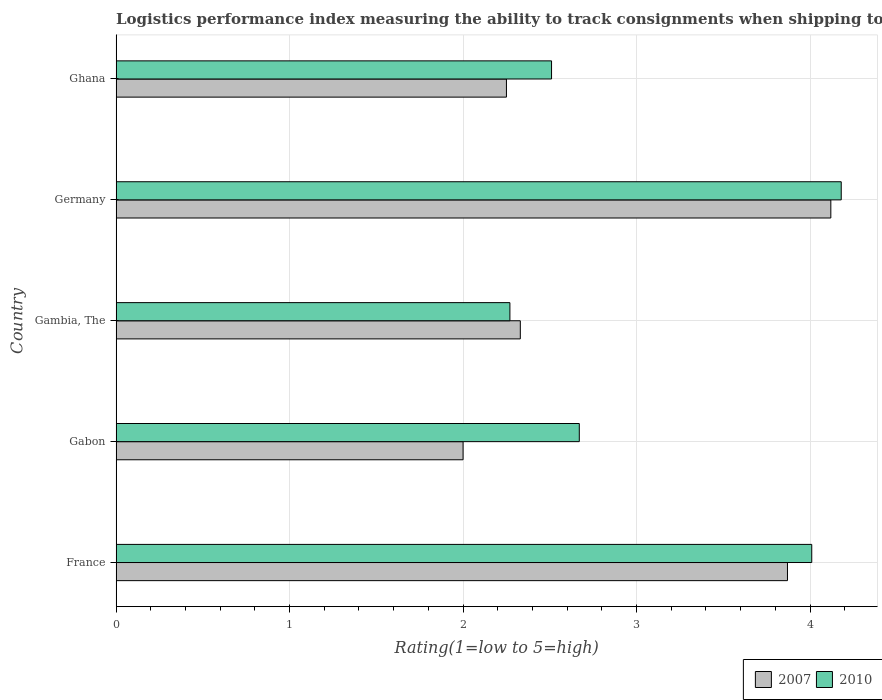How many different coloured bars are there?
Keep it short and to the point. 2. Are the number of bars per tick equal to the number of legend labels?
Keep it short and to the point. Yes. How many bars are there on the 4th tick from the bottom?
Offer a very short reply. 2. What is the Logistic performance index in 2007 in Ghana?
Provide a succinct answer. 2.25. Across all countries, what is the maximum Logistic performance index in 2010?
Give a very brief answer. 4.18. Across all countries, what is the minimum Logistic performance index in 2007?
Your answer should be very brief. 2. In which country was the Logistic performance index in 2007 minimum?
Provide a short and direct response. Gabon. What is the total Logistic performance index in 2007 in the graph?
Give a very brief answer. 14.57. What is the difference between the Logistic performance index in 2007 in Gabon and the Logistic performance index in 2010 in France?
Offer a terse response. -2.01. What is the average Logistic performance index in 2007 per country?
Give a very brief answer. 2.91. What is the difference between the Logistic performance index in 2010 and Logistic performance index in 2007 in Gabon?
Give a very brief answer. 0.67. What is the ratio of the Logistic performance index in 2007 in France to that in Germany?
Your response must be concise. 0.94. Is the Logistic performance index in 2007 in Gambia, The less than that in Germany?
Your response must be concise. Yes. Is the difference between the Logistic performance index in 2010 in Germany and Ghana greater than the difference between the Logistic performance index in 2007 in Germany and Ghana?
Your response must be concise. No. What is the difference between the highest and the second highest Logistic performance index in 2007?
Offer a very short reply. 0.25. What is the difference between the highest and the lowest Logistic performance index in 2007?
Offer a terse response. 2.12. In how many countries, is the Logistic performance index in 2010 greater than the average Logistic performance index in 2010 taken over all countries?
Make the answer very short. 2. Is the sum of the Logistic performance index in 2007 in France and Gambia, The greater than the maximum Logistic performance index in 2010 across all countries?
Your answer should be compact. Yes. What does the 2nd bar from the top in France represents?
Keep it short and to the point. 2007. What does the 2nd bar from the bottom in Gambia, The represents?
Provide a succinct answer. 2010. Are all the bars in the graph horizontal?
Your response must be concise. Yes. Are the values on the major ticks of X-axis written in scientific E-notation?
Your answer should be very brief. No. Does the graph contain any zero values?
Make the answer very short. No. Does the graph contain grids?
Keep it short and to the point. Yes. How many legend labels are there?
Keep it short and to the point. 2. How are the legend labels stacked?
Provide a succinct answer. Horizontal. What is the title of the graph?
Your answer should be very brief. Logistics performance index measuring the ability to track consignments when shipping to a market. Does "1972" appear as one of the legend labels in the graph?
Offer a very short reply. No. What is the label or title of the X-axis?
Ensure brevity in your answer.  Rating(1=low to 5=high). What is the Rating(1=low to 5=high) of 2007 in France?
Keep it short and to the point. 3.87. What is the Rating(1=low to 5=high) of 2010 in France?
Your answer should be very brief. 4.01. What is the Rating(1=low to 5=high) in 2010 in Gabon?
Provide a succinct answer. 2.67. What is the Rating(1=low to 5=high) of 2007 in Gambia, The?
Provide a short and direct response. 2.33. What is the Rating(1=low to 5=high) in 2010 in Gambia, The?
Provide a succinct answer. 2.27. What is the Rating(1=low to 5=high) of 2007 in Germany?
Make the answer very short. 4.12. What is the Rating(1=low to 5=high) of 2010 in Germany?
Make the answer very short. 4.18. What is the Rating(1=low to 5=high) of 2007 in Ghana?
Provide a succinct answer. 2.25. What is the Rating(1=low to 5=high) of 2010 in Ghana?
Provide a succinct answer. 2.51. Across all countries, what is the maximum Rating(1=low to 5=high) in 2007?
Your answer should be very brief. 4.12. Across all countries, what is the maximum Rating(1=low to 5=high) in 2010?
Provide a succinct answer. 4.18. Across all countries, what is the minimum Rating(1=low to 5=high) of 2010?
Your response must be concise. 2.27. What is the total Rating(1=low to 5=high) in 2007 in the graph?
Offer a terse response. 14.57. What is the total Rating(1=low to 5=high) of 2010 in the graph?
Provide a short and direct response. 15.64. What is the difference between the Rating(1=low to 5=high) in 2007 in France and that in Gabon?
Offer a very short reply. 1.87. What is the difference between the Rating(1=low to 5=high) in 2010 in France and that in Gabon?
Your response must be concise. 1.34. What is the difference between the Rating(1=low to 5=high) in 2007 in France and that in Gambia, The?
Provide a short and direct response. 1.54. What is the difference between the Rating(1=low to 5=high) of 2010 in France and that in Gambia, The?
Your response must be concise. 1.74. What is the difference between the Rating(1=low to 5=high) in 2010 in France and that in Germany?
Give a very brief answer. -0.17. What is the difference between the Rating(1=low to 5=high) of 2007 in France and that in Ghana?
Make the answer very short. 1.62. What is the difference between the Rating(1=low to 5=high) of 2007 in Gabon and that in Gambia, The?
Ensure brevity in your answer.  -0.33. What is the difference between the Rating(1=low to 5=high) in 2010 in Gabon and that in Gambia, The?
Your answer should be compact. 0.4. What is the difference between the Rating(1=low to 5=high) of 2007 in Gabon and that in Germany?
Make the answer very short. -2.12. What is the difference between the Rating(1=low to 5=high) in 2010 in Gabon and that in Germany?
Keep it short and to the point. -1.51. What is the difference between the Rating(1=low to 5=high) of 2010 in Gabon and that in Ghana?
Offer a terse response. 0.16. What is the difference between the Rating(1=low to 5=high) in 2007 in Gambia, The and that in Germany?
Your answer should be very brief. -1.79. What is the difference between the Rating(1=low to 5=high) in 2010 in Gambia, The and that in Germany?
Ensure brevity in your answer.  -1.91. What is the difference between the Rating(1=low to 5=high) in 2007 in Gambia, The and that in Ghana?
Your answer should be compact. 0.08. What is the difference between the Rating(1=low to 5=high) of 2010 in Gambia, The and that in Ghana?
Provide a short and direct response. -0.24. What is the difference between the Rating(1=low to 5=high) in 2007 in Germany and that in Ghana?
Provide a succinct answer. 1.87. What is the difference between the Rating(1=low to 5=high) of 2010 in Germany and that in Ghana?
Your response must be concise. 1.67. What is the difference between the Rating(1=low to 5=high) in 2007 in France and the Rating(1=low to 5=high) in 2010 in Gabon?
Provide a short and direct response. 1.2. What is the difference between the Rating(1=low to 5=high) in 2007 in France and the Rating(1=low to 5=high) in 2010 in Gambia, The?
Give a very brief answer. 1.6. What is the difference between the Rating(1=low to 5=high) of 2007 in France and the Rating(1=low to 5=high) of 2010 in Germany?
Offer a terse response. -0.31. What is the difference between the Rating(1=low to 5=high) in 2007 in France and the Rating(1=low to 5=high) in 2010 in Ghana?
Your response must be concise. 1.36. What is the difference between the Rating(1=low to 5=high) in 2007 in Gabon and the Rating(1=low to 5=high) in 2010 in Gambia, The?
Your answer should be very brief. -0.27. What is the difference between the Rating(1=low to 5=high) of 2007 in Gabon and the Rating(1=low to 5=high) of 2010 in Germany?
Offer a terse response. -2.18. What is the difference between the Rating(1=low to 5=high) of 2007 in Gabon and the Rating(1=low to 5=high) of 2010 in Ghana?
Your answer should be very brief. -0.51. What is the difference between the Rating(1=low to 5=high) in 2007 in Gambia, The and the Rating(1=low to 5=high) in 2010 in Germany?
Offer a terse response. -1.85. What is the difference between the Rating(1=low to 5=high) of 2007 in Gambia, The and the Rating(1=low to 5=high) of 2010 in Ghana?
Keep it short and to the point. -0.18. What is the difference between the Rating(1=low to 5=high) in 2007 in Germany and the Rating(1=low to 5=high) in 2010 in Ghana?
Give a very brief answer. 1.61. What is the average Rating(1=low to 5=high) of 2007 per country?
Provide a short and direct response. 2.91. What is the average Rating(1=low to 5=high) of 2010 per country?
Your answer should be very brief. 3.13. What is the difference between the Rating(1=low to 5=high) in 2007 and Rating(1=low to 5=high) in 2010 in France?
Make the answer very short. -0.14. What is the difference between the Rating(1=low to 5=high) of 2007 and Rating(1=low to 5=high) of 2010 in Gabon?
Your answer should be very brief. -0.67. What is the difference between the Rating(1=low to 5=high) in 2007 and Rating(1=low to 5=high) in 2010 in Gambia, The?
Give a very brief answer. 0.06. What is the difference between the Rating(1=low to 5=high) in 2007 and Rating(1=low to 5=high) in 2010 in Germany?
Your answer should be very brief. -0.06. What is the difference between the Rating(1=low to 5=high) in 2007 and Rating(1=low to 5=high) in 2010 in Ghana?
Give a very brief answer. -0.26. What is the ratio of the Rating(1=low to 5=high) in 2007 in France to that in Gabon?
Provide a short and direct response. 1.94. What is the ratio of the Rating(1=low to 5=high) of 2010 in France to that in Gabon?
Ensure brevity in your answer.  1.5. What is the ratio of the Rating(1=low to 5=high) of 2007 in France to that in Gambia, The?
Your answer should be very brief. 1.66. What is the ratio of the Rating(1=low to 5=high) in 2010 in France to that in Gambia, The?
Keep it short and to the point. 1.77. What is the ratio of the Rating(1=low to 5=high) of 2007 in France to that in Germany?
Your answer should be compact. 0.94. What is the ratio of the Rating(1=low to 5=high) in 2010 in France to that in Germany?
Your answer should be compact. 0.96. What is the ratio of the Rating(1=low to 5=high) in 2007 in France to that in Ghana?
Your response must be concise. 1.72. What is the ratio of the Rating(1=low to 5=high) of 2010 in France to that in Ghana?
Ensure brevity in your answer.  1.6. What is the ratio of the Rating(1=low to 5=high) of 2007 in Gabon to that in Gambia, The?
Your answer should be compact. 0.86. What is the ratio of the Rating(1=low to 5=high) in 2010 in Gabon to that in Gambia, The?
Offer a very short reply. 1.18. What is the ratio of the Rating(1=low to 5=high) in 2007 in Gabon to that in Germany?
Keep it short and to the point. 0.49. What is the ratio of the Rating(1=low to 5=high) of 2010 in Gabon to that in Germany?
Ensure brevity in your answer.  0.64. What is the ratio of the Rating(1=low to 5=high) of 2010 in Gabon to that in Ghana?
Provide a short and direct response. 1.06. What is the ratio of the Rating(1=low to 5=high) in 2007 in Gambia, The to that in Germany?
Your answer should be very brief. 0.57. What is the ratio of the Rating(1=low to 5=high) in 2010 in Gambia, The to that in Germany?
Offer a terse response. 0.54. What is the ratio of the Rating(1=low to 5=high) in 2007 in Gambia, The to that in Ghana?
Ensure brevity in your answer.  1.04. What is the ratio of the Rating(1=low to 5=high) of 2010 in Gambia, The to that in Ghana?
Ensure brevity in your answer.  0.9. What is the ratio of the Rating(1=low to 5=high) of 2007 in Germany to that in Ghana?
Your response must be concise. 1.83. What is the ratio of the Rating(1=low to 5=high) in 2010 in Germany to that in Ghana?
Provide a short and direct response. 1.67. What is the difference between the highest and the second highest Rating(1=low to 5=high) in 2007?
Offer a terse response. 0.25. What is the difference between the highest and the second highest Rating(1=low to 5=high) in 2010?
Offer a terse response. 0.17. What is the difference between the highest and the lowest Rating(1=low to 5=high) in 2007?
Your response must be concise. 2.12. What is the difference between the highest and the lowest Rating(1=low to 5=high) of 2010?
Your answer should be compact. 1.91. 